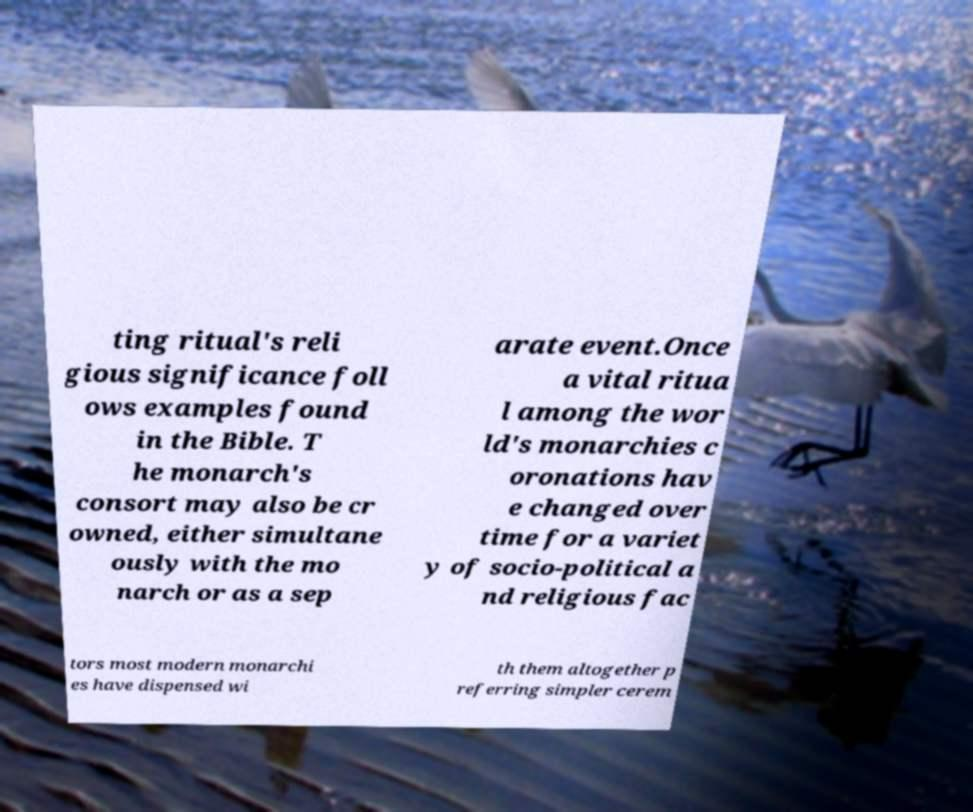What messages or text are displayed in this image? I need them in a readable, typed format. ting ritual's reli gious significance foll ows examples found in the Bible. T he monarch's consort may also be cr owned, either simultane ously with the mo narch or as a sep arate event.Once a vital ritua l among the wor ld's monarchies c oronations hav e changed over time for a variet y of socio-political a nd religious fac tors most modern monarchi es have dispensed wi th them altogether p referring simpler cerem 